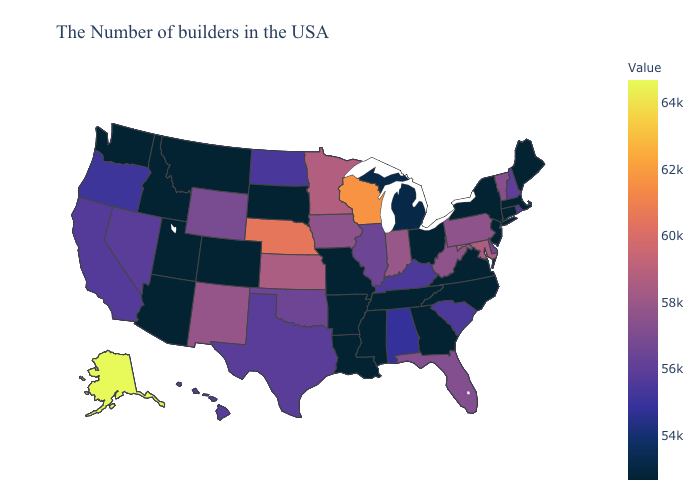Which states have the highest value in the USA?
Concise answer only. Alaska. Does Arkansas have a lower value than Wyoming?
Give a very brief answer. Yes. Does Kansas have a lower value than Mississippi?
Keep it brief. No. Which states have the lowest value in the Northeast?
Keep it brief. Maine, Massachusetts, Connecticut, New York, New Jersey. 